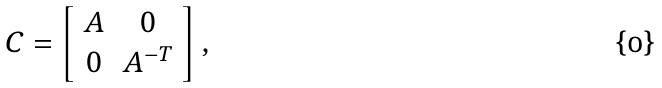Convert formula to latex. <formula><loc_0><loc_0><loc_500><loc_500>C = \left [ \begin{array} { c c } A & 0 \\ 0 & A ^ { - T } \end{array} \right ] ,</formula> 